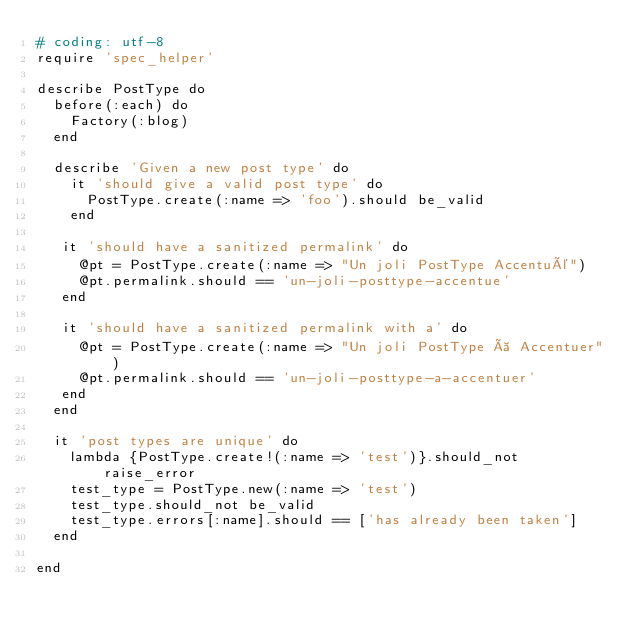Convert code to text. <code><loc_0><loc_0><loc_500><loc_500><_Ruby_># coding: utf-8
require 'spec_helper'

describe PostType do
  before(:each) do
    Factory(:blog)
  end
  
  describe 'Given a new post type' do
    it 'should give a valid post type' do
      PostType.create(:name => 'foo').should be_valid
    end
   
   it 'should have a sanitized permalink' do
     @pt = PostType.create(:name => "Un joli PostType Accentué")
     @pt.permalink.should == 'un-joli-posttype-accentue'
   end
    
   it 'should have a sanitized permalink with a' do
     @pt = PostType.create(:name => "Un joli PostType à Accentuer")
     @pt.permalink.should == 'un-joli-posttype-a-accentuer'
   end
  end
  
  it 'post types are unique' do
    lambda {PostType.create!(:name => 'test')}.should_not raise_error
    test_type = PostType.new(:name => 'test')
    test_type.should_not be_valid
    test_type.errors[:name].should == ['has already been taken']
  end
  
end
</code> 